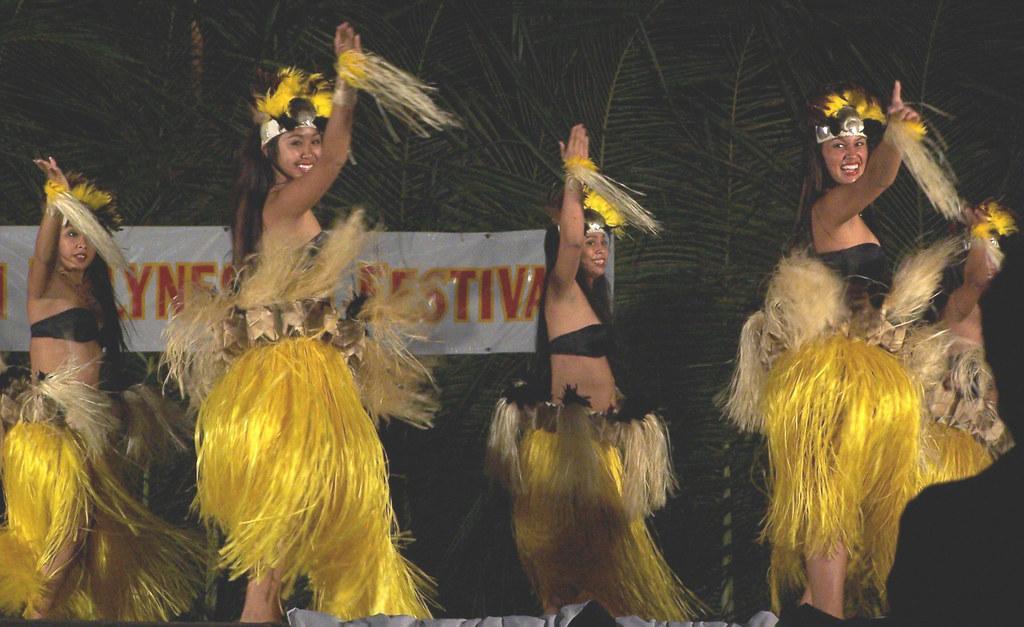Please provide a concise description of this image. In the picture we can see some women are dancing with a different costumes and they are smiling and in the background, we can see a wall with a banner which is white in color written on it as some festival on it. 